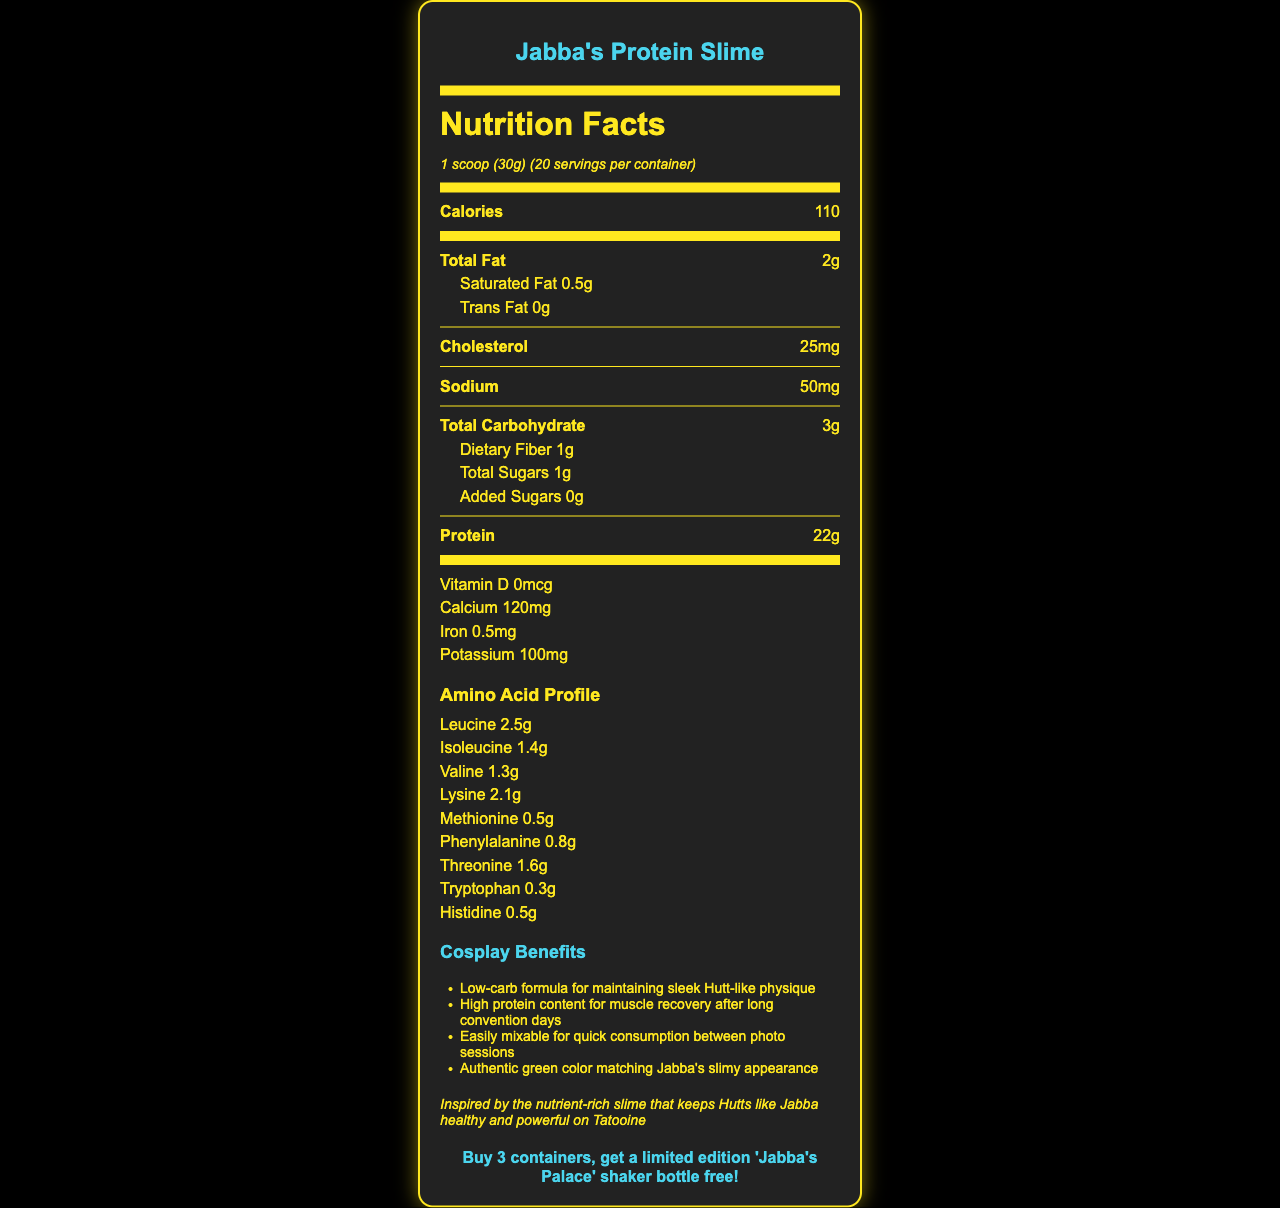what is the serving size of Jabba's Protein Slime? The serving size is directly stated as "1 scoop (30g)" in the document.
Answer: 1 scoop (30g) how many calories are in one serving? The document states that each serving has 110 calories.
Answer: 110 how much protein does each serving contain? The protein content per serving is listed as 22 grams.
Answer: 22g how many servings are in one container? The document mentions there are 20 servings per container.
Answer: 20 what is the total carbohydrate content per serving? The total carbohydrate content per serving is given as 3 grams.
Answer: 3g what is the amino acid content of leucine per serving? The amino acid profile lists leucine as 2.5 grams per serving.
Answer: 2.5g which nutrient has higher content: calcium or potassium? The content of calcium is 120mg, whereas potassium is 100mg.
Answer: Calcium does Jabba's Protein Slime contain any added sugars? The document specifies that there are 0 grams of added sugars.
Answer: No what allergens are present in this product? The allergen information notes that the product contains milk.
Answer: Milk what is the recommended use for optimal results? The recommended use is detailed in the document.
Answer: Mix 1 scoop with 8-10 oz of water or milk substitute. Consume 1-3 servings daily for optimal results. what unique color benefit does Jabba's Protein Slime provide for cosplayers? The cosplay benefits section mentions the authentic green color as one of the benefits.
Answer: Authentic green color matching Jabba's slimy appearance how much dietary fiber is in one serving? The dietary fiber content per serving is listed as 1 gram.
Answer: 1g consume Jabba’s Protein Slime gives you A. More calories than protein B. Less calories than protein C. Equal calories and protein Each serving has 110 calories and 22 grams of protein. Calories are less than the protein amount.
Answer: B. Less calories than protein which micronutrient is present in the least amount? A. Vitamin D B. Iron C. Potassium D. Calcium The micronutrient amount for Vitamin D is 0mcg, which is the least listed.
Answer: A how can you get a 'Jabba's Palace' shaker bottle for free? The special offer section mentions that if you buy three containers, you get the shaker bottle for free.
Answer: Buy 3 containers is this product suitable for people who are lactose intolerant? The allergen information states that the product contains milk, which may not be suitable for lactose-intolerant individuals.
Answer: No summarize the main idea of the document in one sentence. The document primarily promotes the nutritional benefits and unique qualities of Jabba's Protein Slime for cosplay and fitness enthusiasts.
Answer: Jabba's Protein Slime is a low-carb, high-protein supplement with a complete amino acid profile, suitable for fitness-conscious cosplayers looking to maintain a Jabba-like physique, with a special offer available at conventions. how much calcium should you consume daily? The document does not provide any information on the recommended daily intake of calcium.
Answer: Not enough information explain why Jabba's Protein Slime is particularly appealing for Star Wars cosplayers. The cosplay benefits section lists these specific points, making it appealing for Star Wars cosplayers.
Answer: It offers low-carb content for maintaining physique, high protein for muscle recovery, quick mixability, and an authentic green color matching Jabba's appearance. 